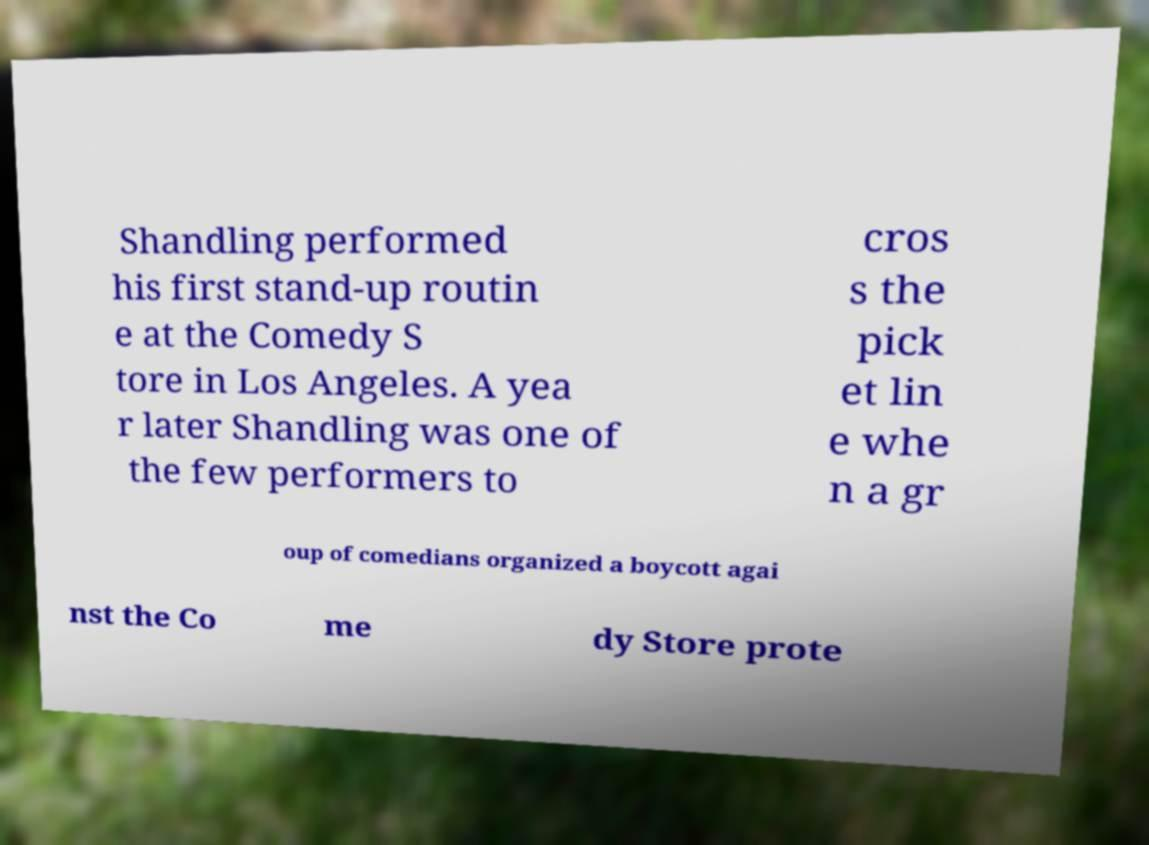For documentation purposes, I need the text within this image transcribed. Could you provide that? Shandling performed his first stand-up routin e at the Comedy S tore in Los Angeles. A yea r later Shandling was one of the few performers to cros s the pick et lin e whe n a gr oup of comedians organized a boycott agai nst the Co me dy Store prote 